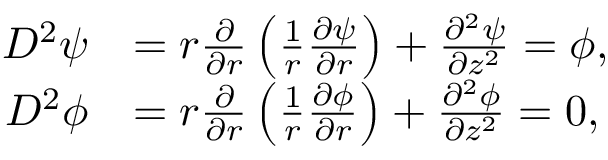Convert formula to latex. <formula><loc_0><loc_0><loc_500><loc_500>\begin{array} { r l } { D ^ { 2 } \psi } & { = r \frac { \partial } { \partial r } \left ( \frac { 1 } { r } \frac { \partial \psi } { \partial r } \right ) + \frac { \partial ^ { 2 } \psi } { \partial z ^ { 2 } } = \phi , } \\ { D ^ { 2 } \phi } & { = r \frac { \partial } { \partial r } \left ( \frac { 1 } { r } \frac { \partial \phi } { \partial r } \right ) + \frac { \partial ^ { 2 } \phi } { \partial z ^ { 2 } } = 0 , } \end{array}</formula> 